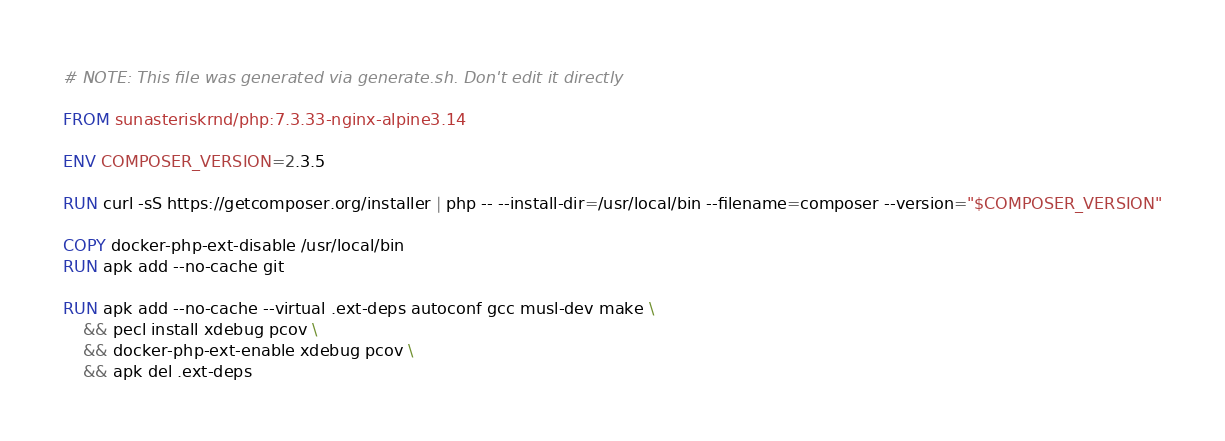<code> <loc_0><loc_0><loc_500><loc_500><_Dockerfile_># NOTE: This file was generated via generate.sh. Don't edit it directly

FROM sunasteriskrnd/php:7.3.33-nginx-alpine3.14

ENV COMPOSER_VERSION=2.3.5

RUN curl -sS https://getcomposer.org/installer | php -- --install-dir=/usr/local/bin --filename=composer --version="$COMPOSER_VERSION"

COPY docker-php-ext-disable /usr/local/bin
RUN apk add --no-cache git

RUN apk add --no-cache --virtual .ext-deps autoconf gcc musl-dev make \
    && pecl install xdebug pcov \
    && docker-php-ext-enable xdebug pcov \
    && apk del .ext-deps
</code> 